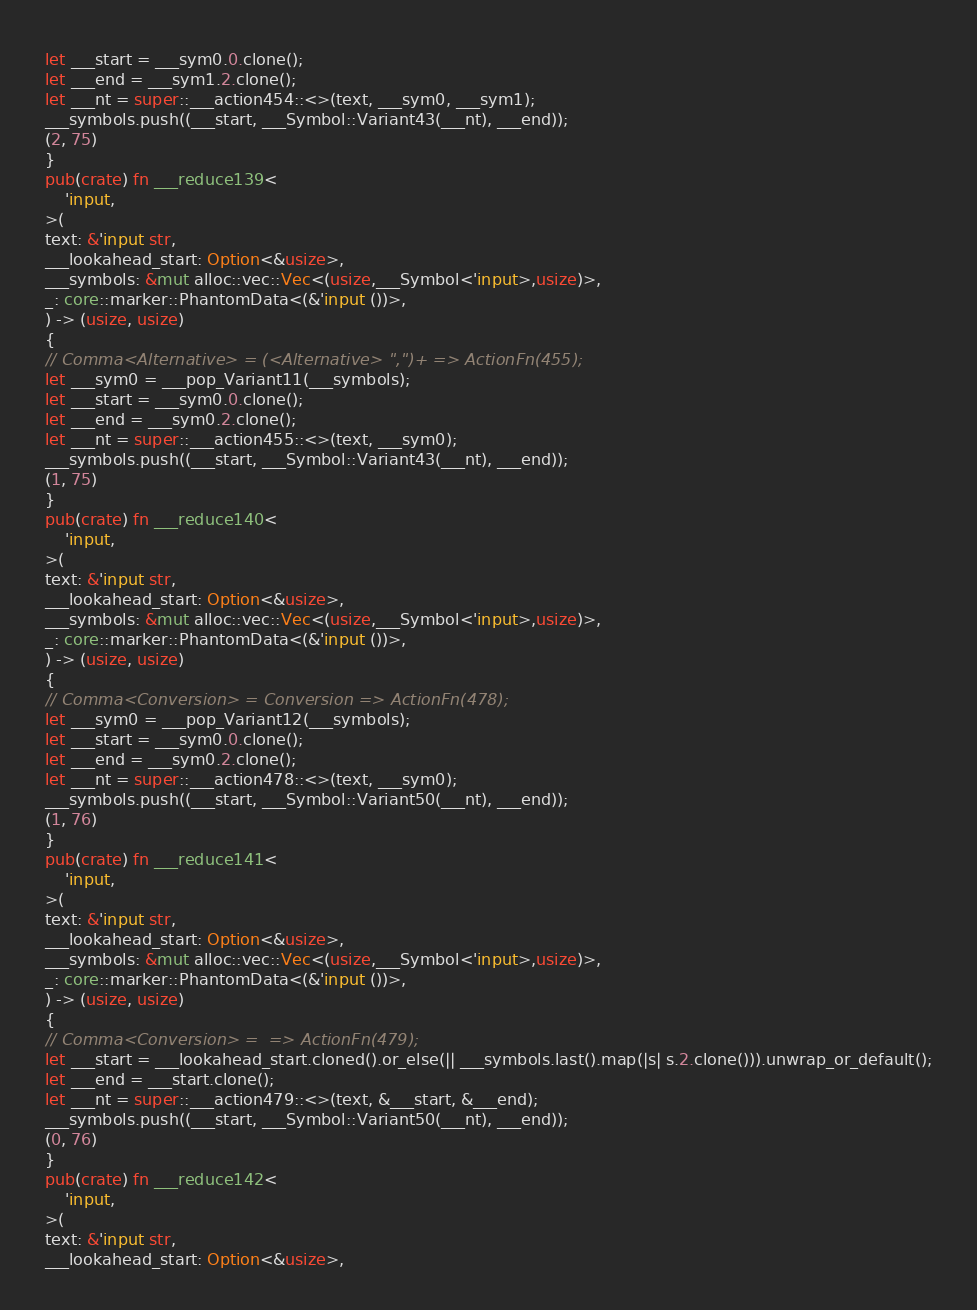<code> <loc_0><loc_0><loc_500><loc_500><_Rust_>let ___start = ___sym0.0.clone();
let ___end = ___sym1.2.clone();
let ___nt = super::___action454::<>(text, ___sym0, ___sym1);
___symbols.push((___start, ___Symbol::Variant43(___nt), ___end));
(2, 75)
}
pub(crate) fn ___reduce139<
    'input,
>(
text: &'input str,
___lookahead_start: Option<&usize>,
___symbols: &mut alloc::vec::Vec<(usize,___Symbol<'input>,usize)>,
_: core::marker::PhantomData<(&'input ())>,
) -> (usize, usize)
{
// Comma<Alternative> = (<Alternative> ",")+ => ActionFn(455);
let ___sym0 = ___pop_Variant11(___symbols);
let ___start = ___sym0.0.clone();
let ___end = ___sym0.2.clone();
let ___nt = super::___action455::<>(text, ___sym0);
___symbols.push((___start, ___Symbol::Variant43(___nt), ___end));
(1, 75)
}
pub(crate) fn ___reduce140<
    'input,
>(
text: &'input str,
___lookahead_start: Option<&usize>,
___symbols: &mut alloc::vec::Vec<(usize,___Symbol<'input>,usize)>,
_: core::marker::PhantomData<(&'input ())>,
) -> (usize, usize)
{
// Comma<Conversion> = Conversion => ActionFn(478);
let ___sym0 = ___pop_Variant12(___symbols);
let ___start = ___sym0.0.clone();
let ___end = ___sym0.2.clone();
let ___nt = super::___action478::<>(text, ___sym0);
___symbols.push((___start, ___Symbol::Variant50(___nt), ___end));
(1, 76)
}
pub(crate) fn ___reduce141<
    'input,
>(
text: &'input str,
___lookahead_start: Option<&usize>,
___symbols: &mut alloc::vec::Vec<(usize,___Symbol<'input>,usize)>,
_: core::marker::PhantomData<(&'input ())>,
) -> (usize, usize)
{
// Comma<Conversion> =  => ActionFn(479);
let ___start = ___lookahead_start.cloned().or_else(|| ___symbols.last().map(|s| s.2.clone())).unwrap_or_default();
let ___end = ___start.clone();
let ___nt = super::___action479::<>(text, &___start, &___end);
___symbols.push((___start, ___Symbol::Variant50(___nt), ___end));
(0, 76)
}
pub(crate) fn ___reduce142<
    'input,
>(
text: &'input str,
___lookahead_start: Option<&usize>,</code> 